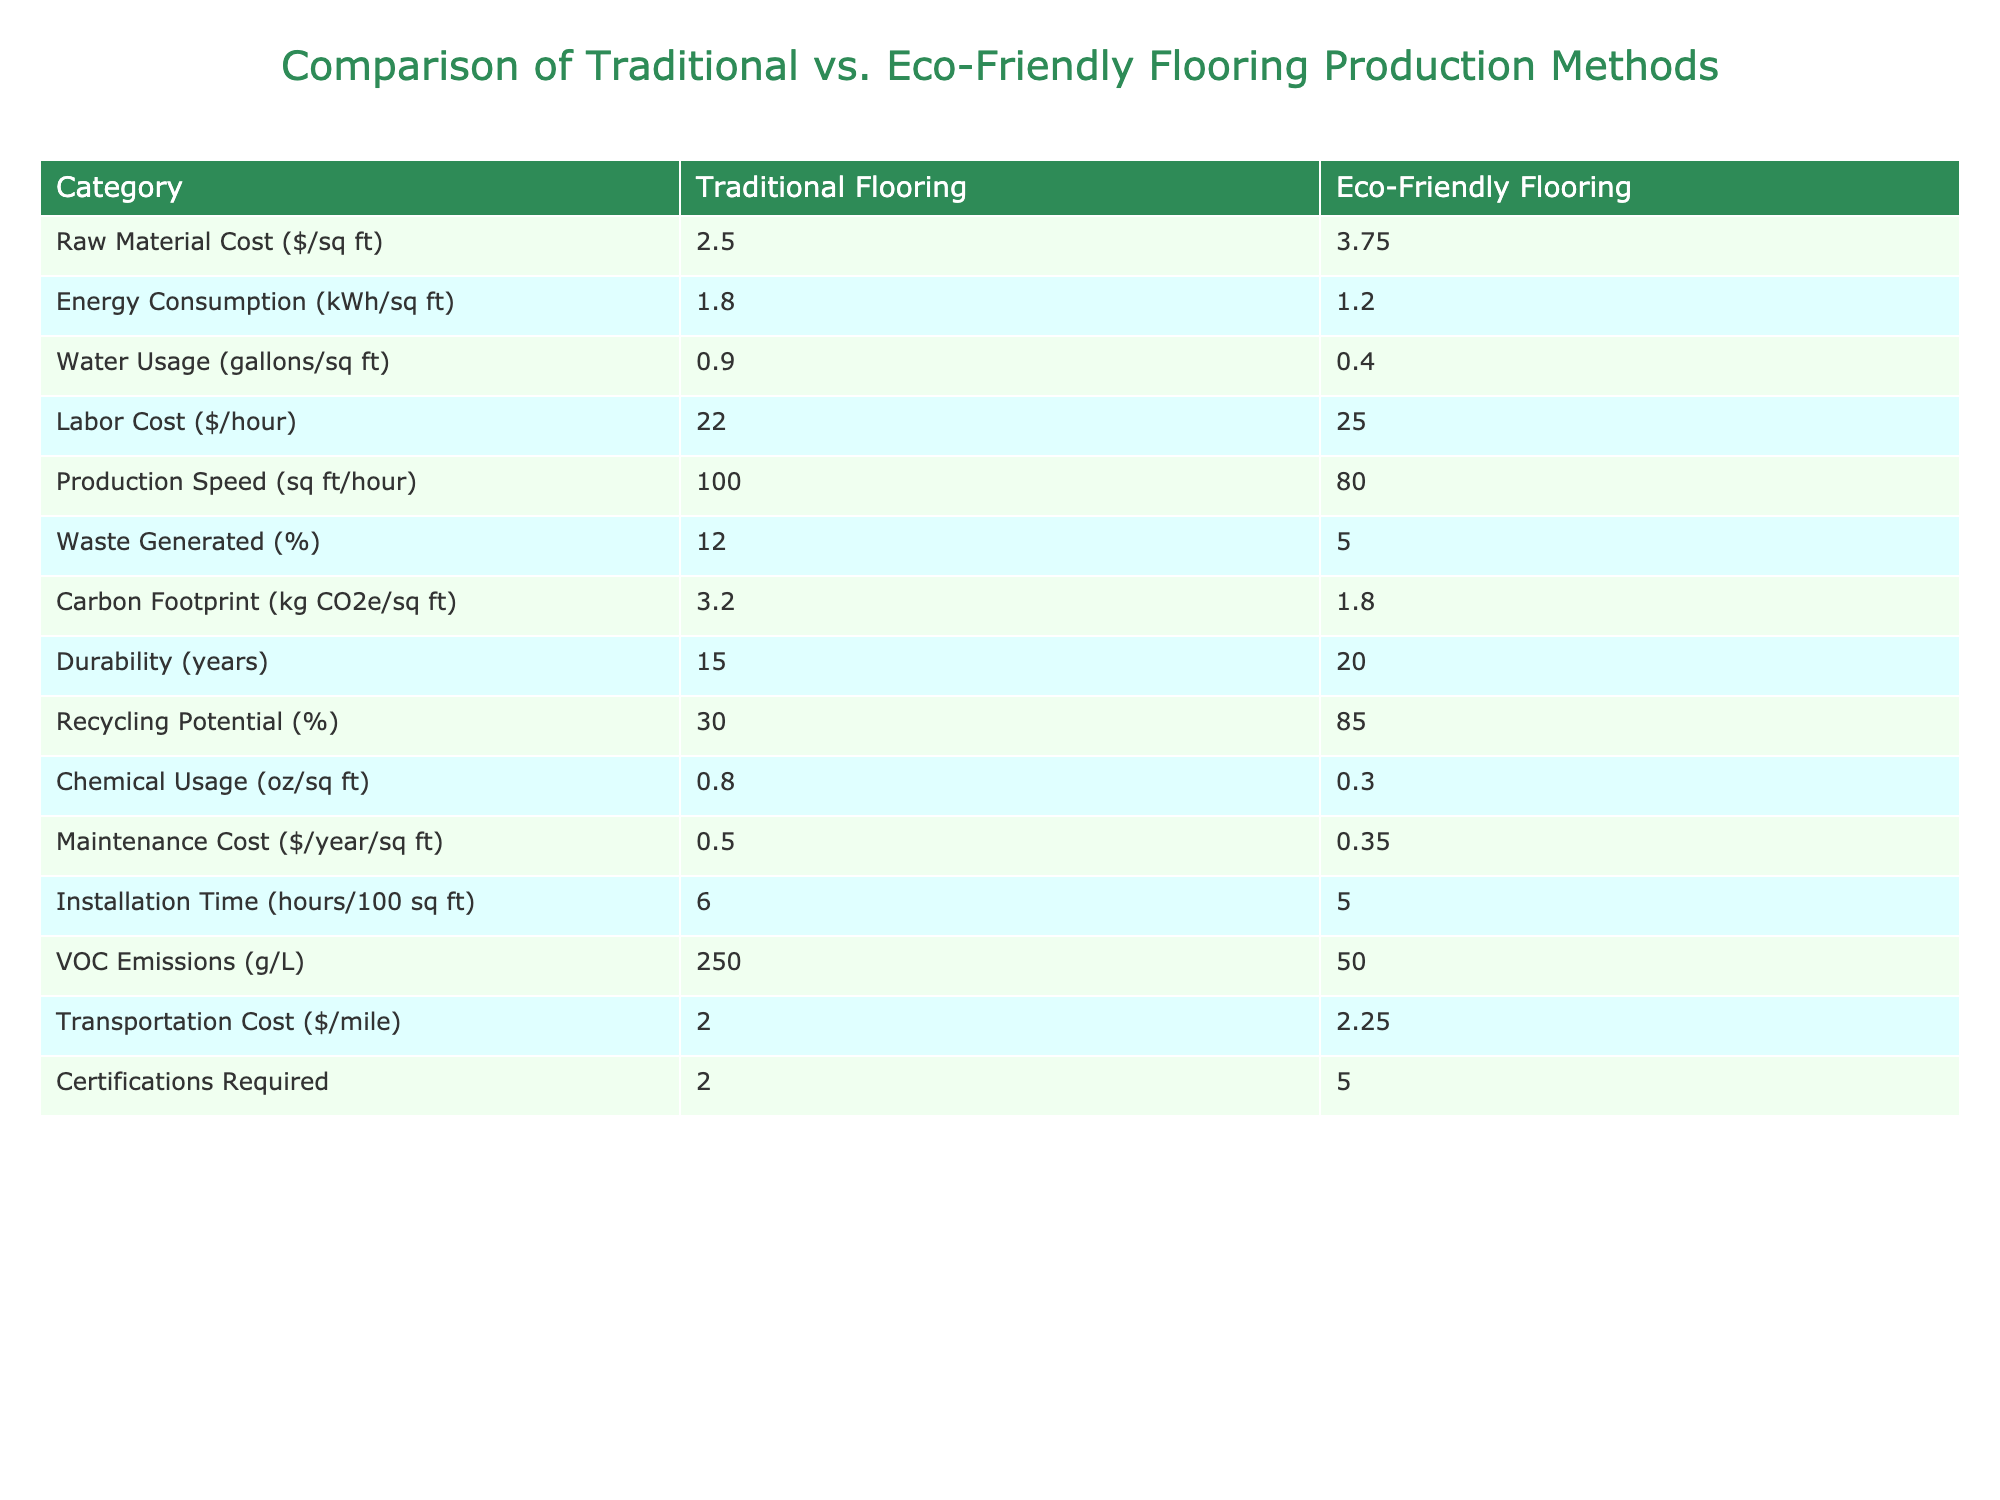What is the raw material cost per square foot for eco-friendly flooring? The table shows that the raw material cost for eco-friendly flooring is 3.75 dollars per square foot. This value is directly listed under the "Eco-Friendly Flooring" column in the "Raw Material Cost" row.
Answer: 3.75 How much energy does traditional flooring production consume (in kWh/sq ft)? The table indicates that traditional flooring production consumes 1.8 kWh per square foot. This information is found directly in the "Traditional Flooring" column under the "Energy Consumption" row.
Answer: 1.8 Which flooring option has a lower carbon footprint per square foot? The carbon footprint for traditional flooring is 3.2 kg CO2e per square foot, while eco-friendly flooring has a carbon footprint of 1.8 kg CO2e per square foot. Since 1.8 is less than 3.2, eco-friendly flooring has a lower carbon footprint.
Answer: Eco-friendly flooring What is the difference in waste generated between traditional and eco-friendly flooring? Traditional flooring generates 12% waste while eco-friendly flooring generates 5% waste. The difference can be calculated as 12 - 5 = 7%. Thus, traditional flooring generates 7% more waste than eco-friendly flooring.
Answer: 7% If you wanted to install 200 square feet of flooring, what would be the total labor cost for both traditional and eco-friendly options? For traditional flooring, the labor cost is 22 dollars per hour with a production speed of 100 sq ft/hour; thus, it would take 2 hours (200/100). Total labor cost is 2 hours x 22 dollars/hour = 44 dollars. For eco-friendly flooring, with a speed of 80 sq ft/hour, it would take 2.5 hours (200/80). Total labor cost is 2.5 hours x 25 dollars/hour = 62.5 dollars. Adding both gives 44 + 62.5 = 106.5 dollars.
Answer: 106.5 Is the installation time for eco-friendly flooring less than traditional flooring? The installation time for traditional flooring is 6 hours per 100 sq ft and is 5 hours for eco-friendly flooring. Since 5 hours is less than 6 hours, it verifies that the installation time for eco-friendly flooring is indeed less.
Answer: Yes 